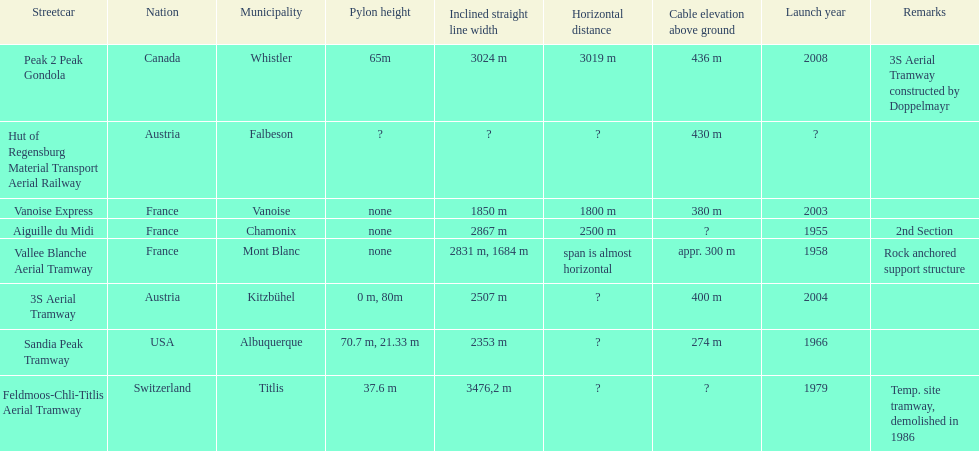At least how many aerial tramways were inaugurated after 1970? 4. 